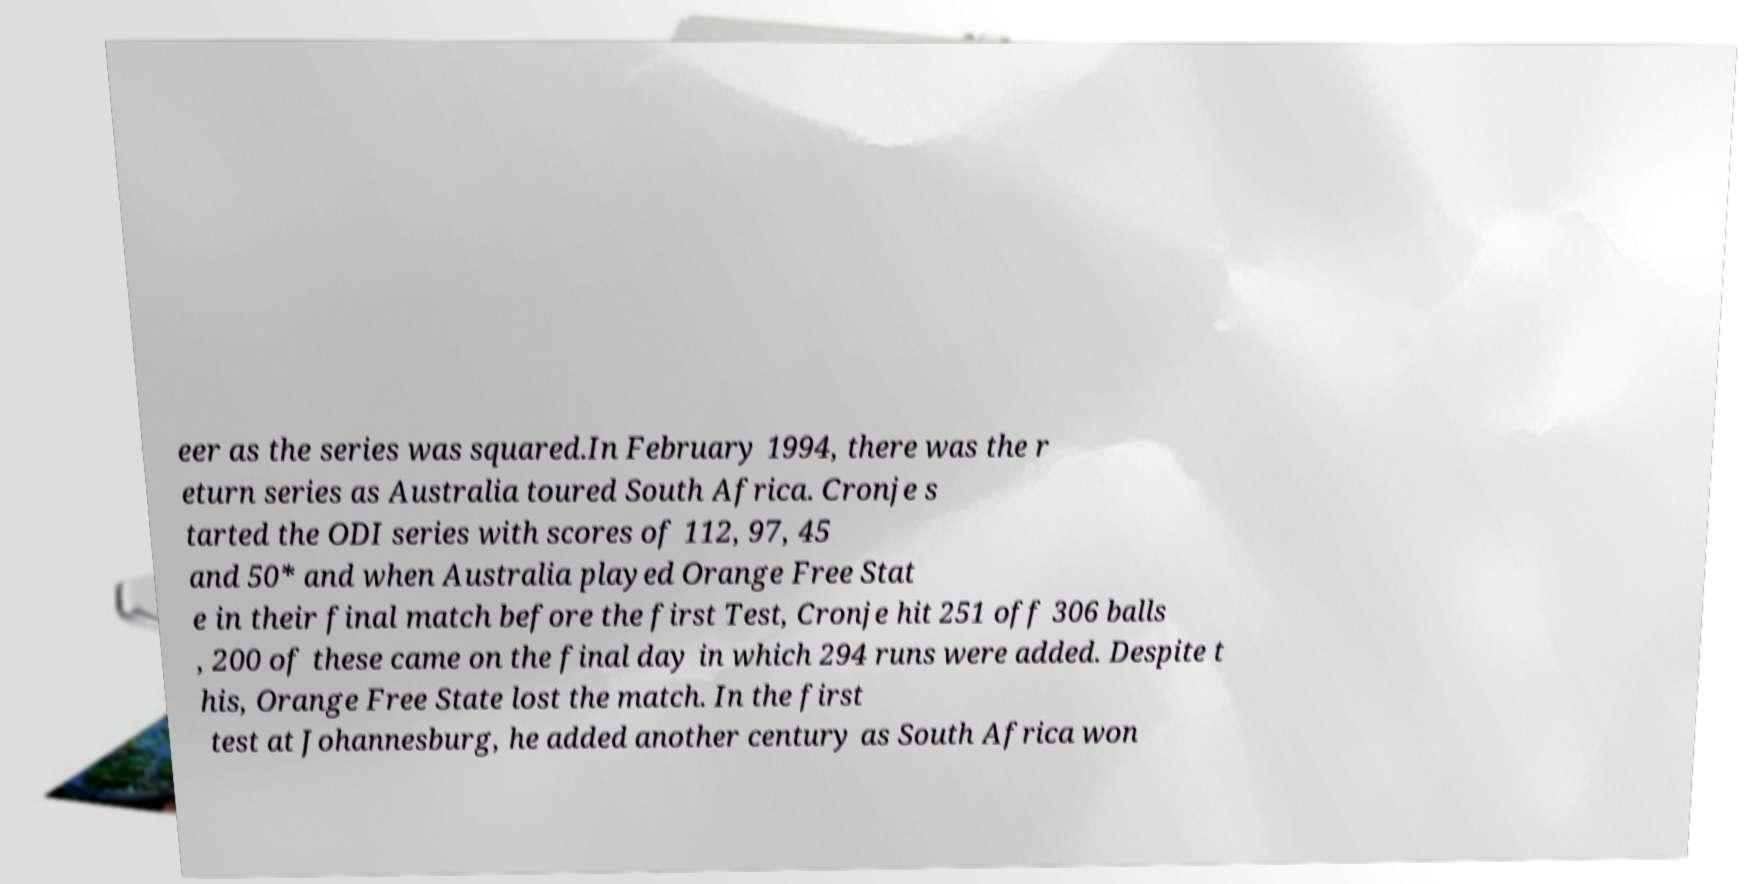Could you assist in decoding the text presented in this image and type it out clearly? eer as the series was squared.In February 1994, there was the r eturn series as Australia toured South Africa. Cronje s tarted the ODI series with scores of 112, 97, 45 and 50* and when Australia played Orange Free Stat e in their final match before the first Test, Cronje hit 251 off 306 balls , 200 of these came on the final day in which 294 runs were added. Despite t his, Orange Free State lost the match. In the first test at Johannesburg, he added another century as South Africa won 